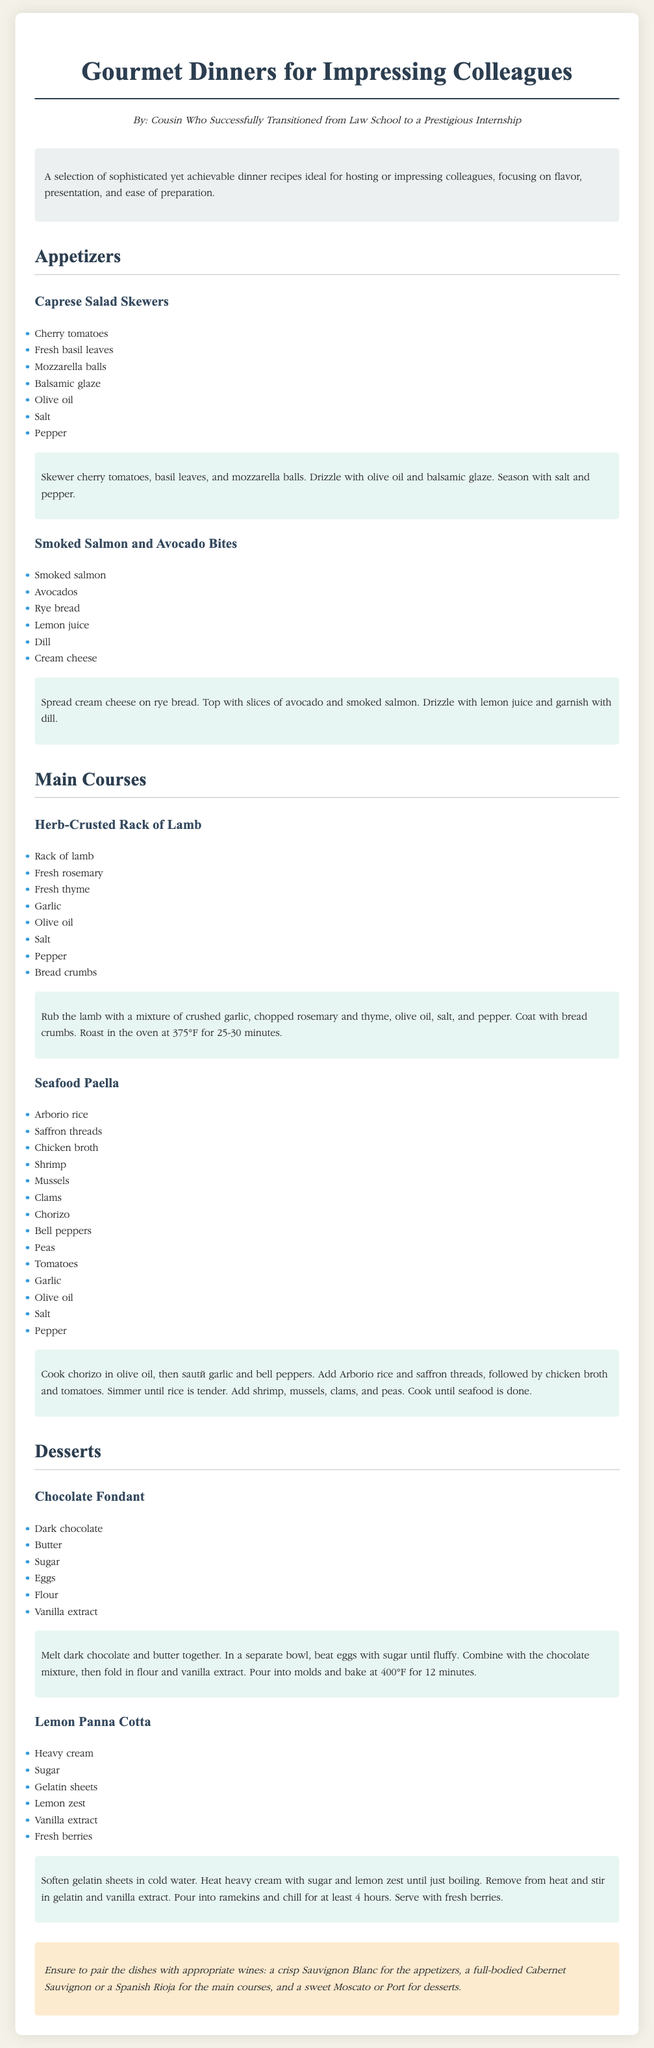What is the name of the first appetizer? The first appetizer listed under appetizers is "Caprese Salad Skewers."
Answer: Caprese Salad Skewers How many main courses are included? The document features two main courses: "Herb-Crusted Rack of Lamb" and "Seafood Paella."
Answer: 2 What is the primary herb used in the rack of lamb recipe? The primary herb used in the herb-crusted rack of lamb recipe is "rosemary."
Answer: rosemary What must be done to the gelatin sheets before use in the dessert? The gelatin sheets must be softened in cold water before being added to the mixture.
Answer: softened in cold water Which dessert is baked at 400°F? The dessert that is baked at 400°F is "Chocolate Fondant."
Answer: Chocolate Fondant What type of wine is recommended for the appetizers? A "crisp Sauvignon Blanc" is recommended to pair with the appetizers.
Answer: crisp Sauvignon Blanc 